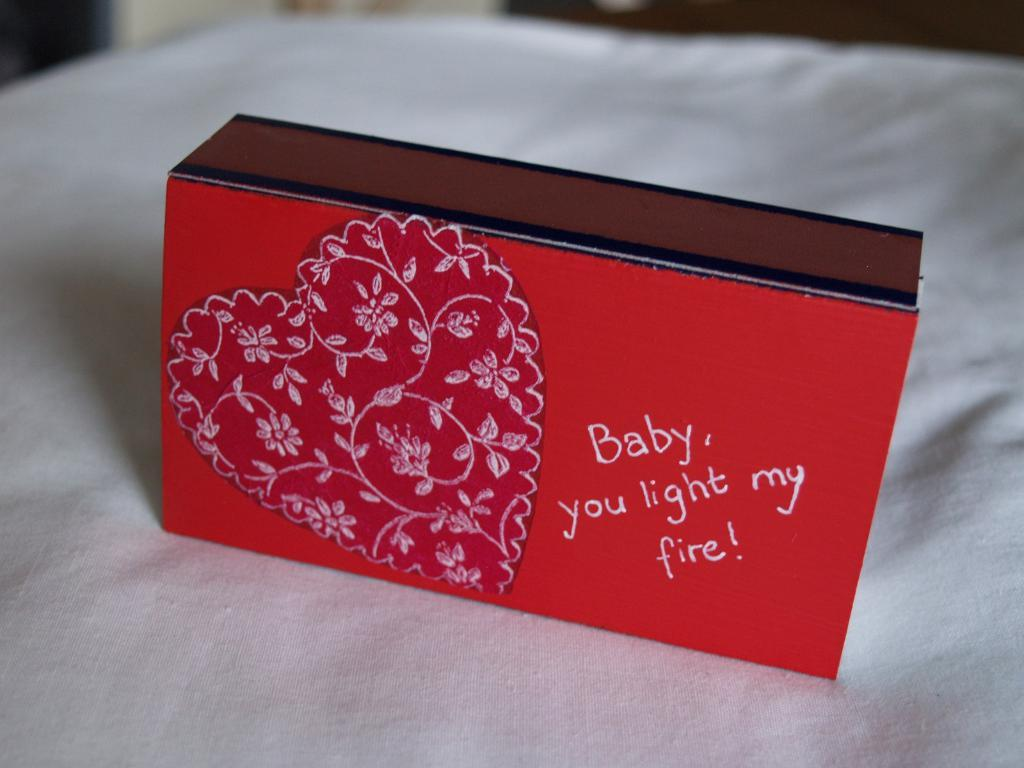Provide a one-sentence caption for the provided image. A valentine's surprise must be hidden in this red heart-adorned match box, with the wording 'Baby you light my fire!'. 